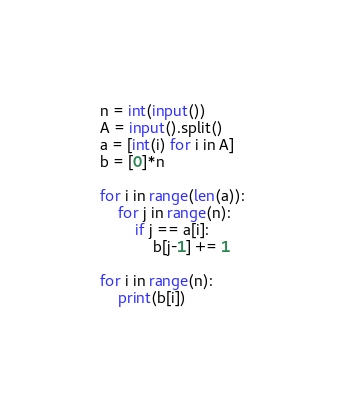Convert code to text. <code><loc_0><loc_0><loc_500><loc_500><_Python_>n = int(input())
A = input().split()
a = [int(i) for i in A]
b = [0]*n

for i in range(len(a)):
    for j in range(n):
        if j == a[i]:
            b[j-1] += 1

for i in range(n):
    print(b[i])</code> 